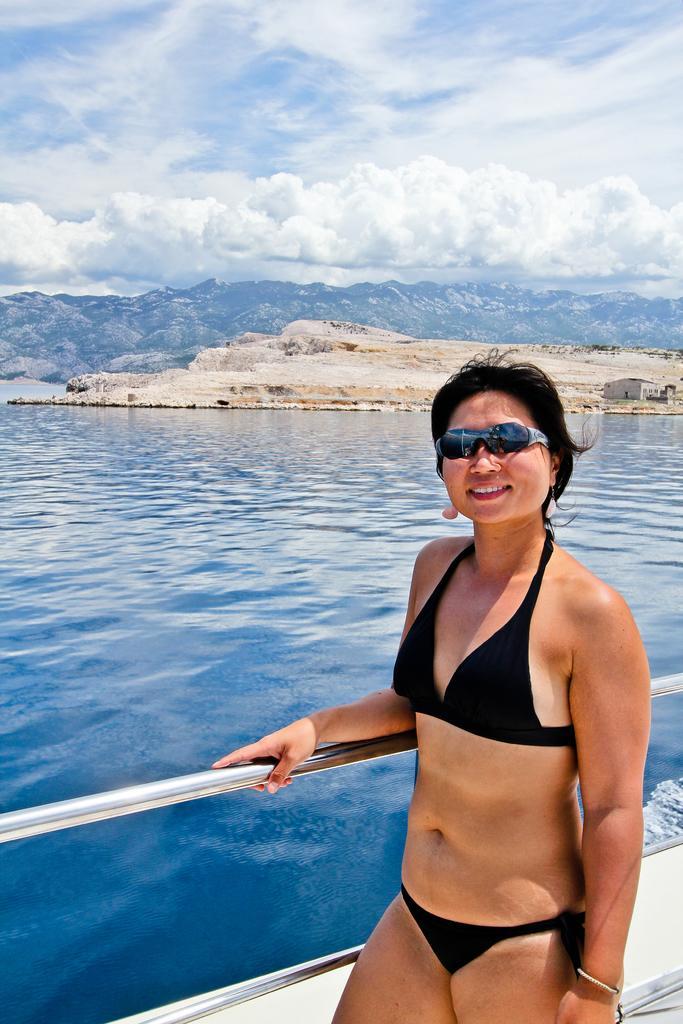Please provide a concise description of this image. In this image we can see there is a girl standing. And there is a steel rod. In the back there is water, Mountain, and a cloudy sky. 